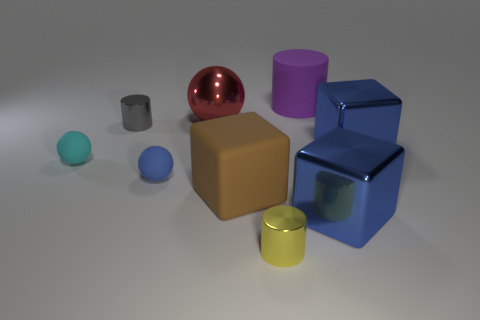Subtract all green balls. How many blue blocks are left? 2 Subtract all metal cubes. How many cubes are left? 1 Subtract 1 cubes. How many cubes are left? 2 Subtract all blocks. How many objects are left? 6 Subtract 0 purple balls. How many objects are left? 9 Subtract all brown matte cubes. Subtract all tiny yellow shiny cylinders. How many objects are left? 7 Add 5 big matte cubes. How many big matte cubes are left? 6 Add 9 purple rubber things. How many purple rubber things exist? 10 